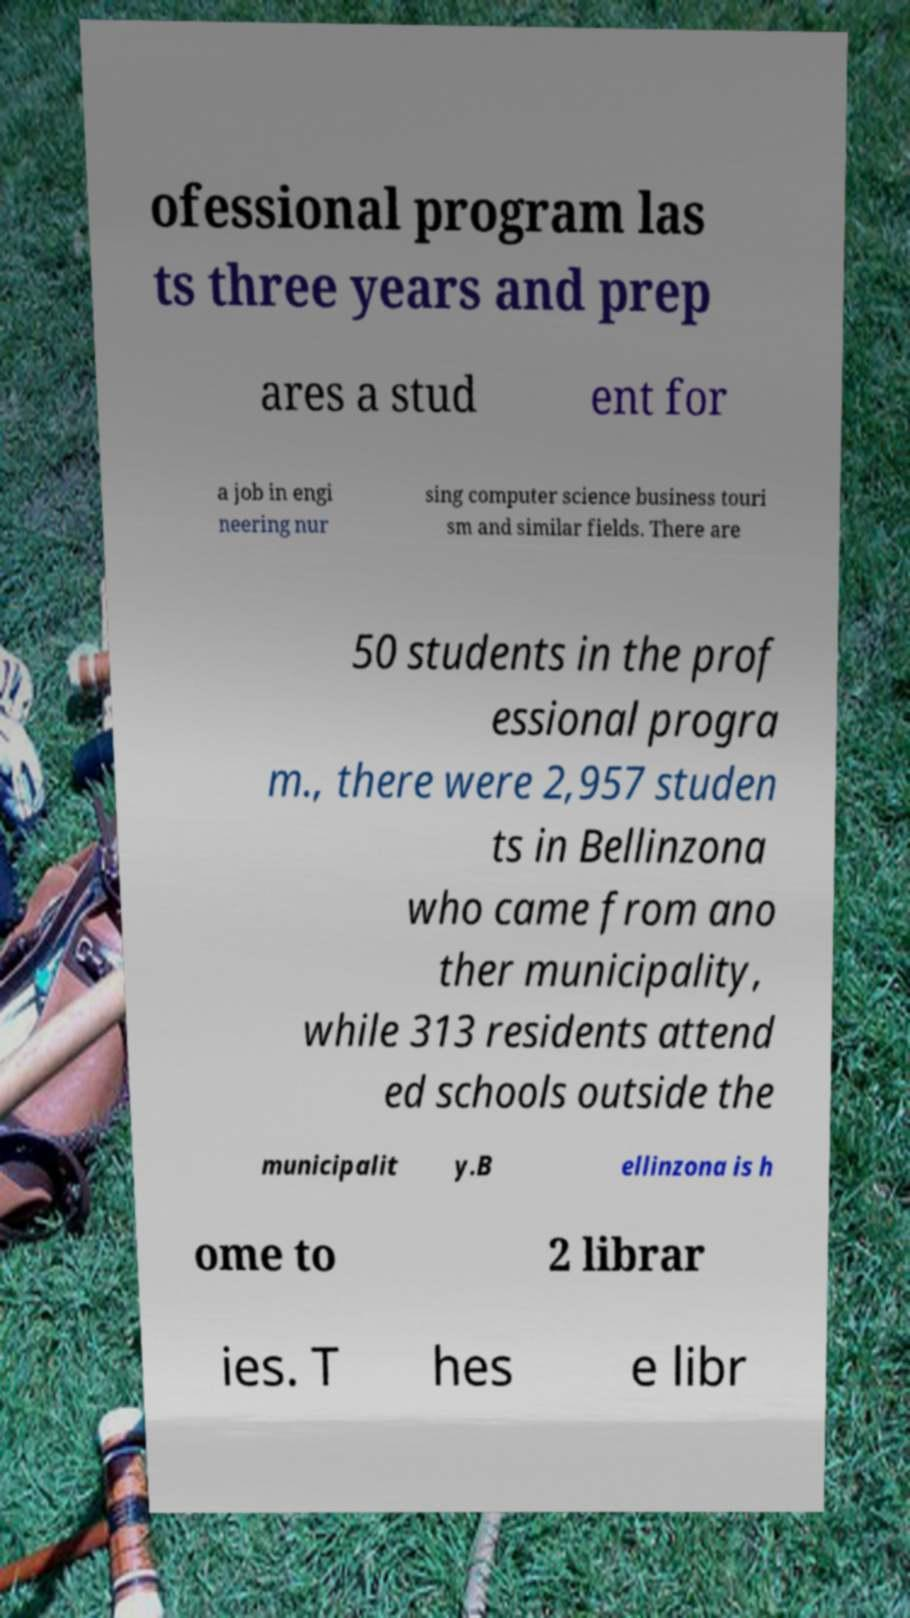Please read and relay the text visible in this image. What does it say? ofessional program las ts three years and prep ares a stud ent for a job in engi neering nur sing computer science business touri sm and similar fields. There are 50 students in the prof essional progra m., there were 2,957 studen ts in Bellinzona who came from ano ther municipality, while 313 residents attend ed schools outside the municipalit y.B ellinzona is h ome to 2 librar ies. T hes e libr 